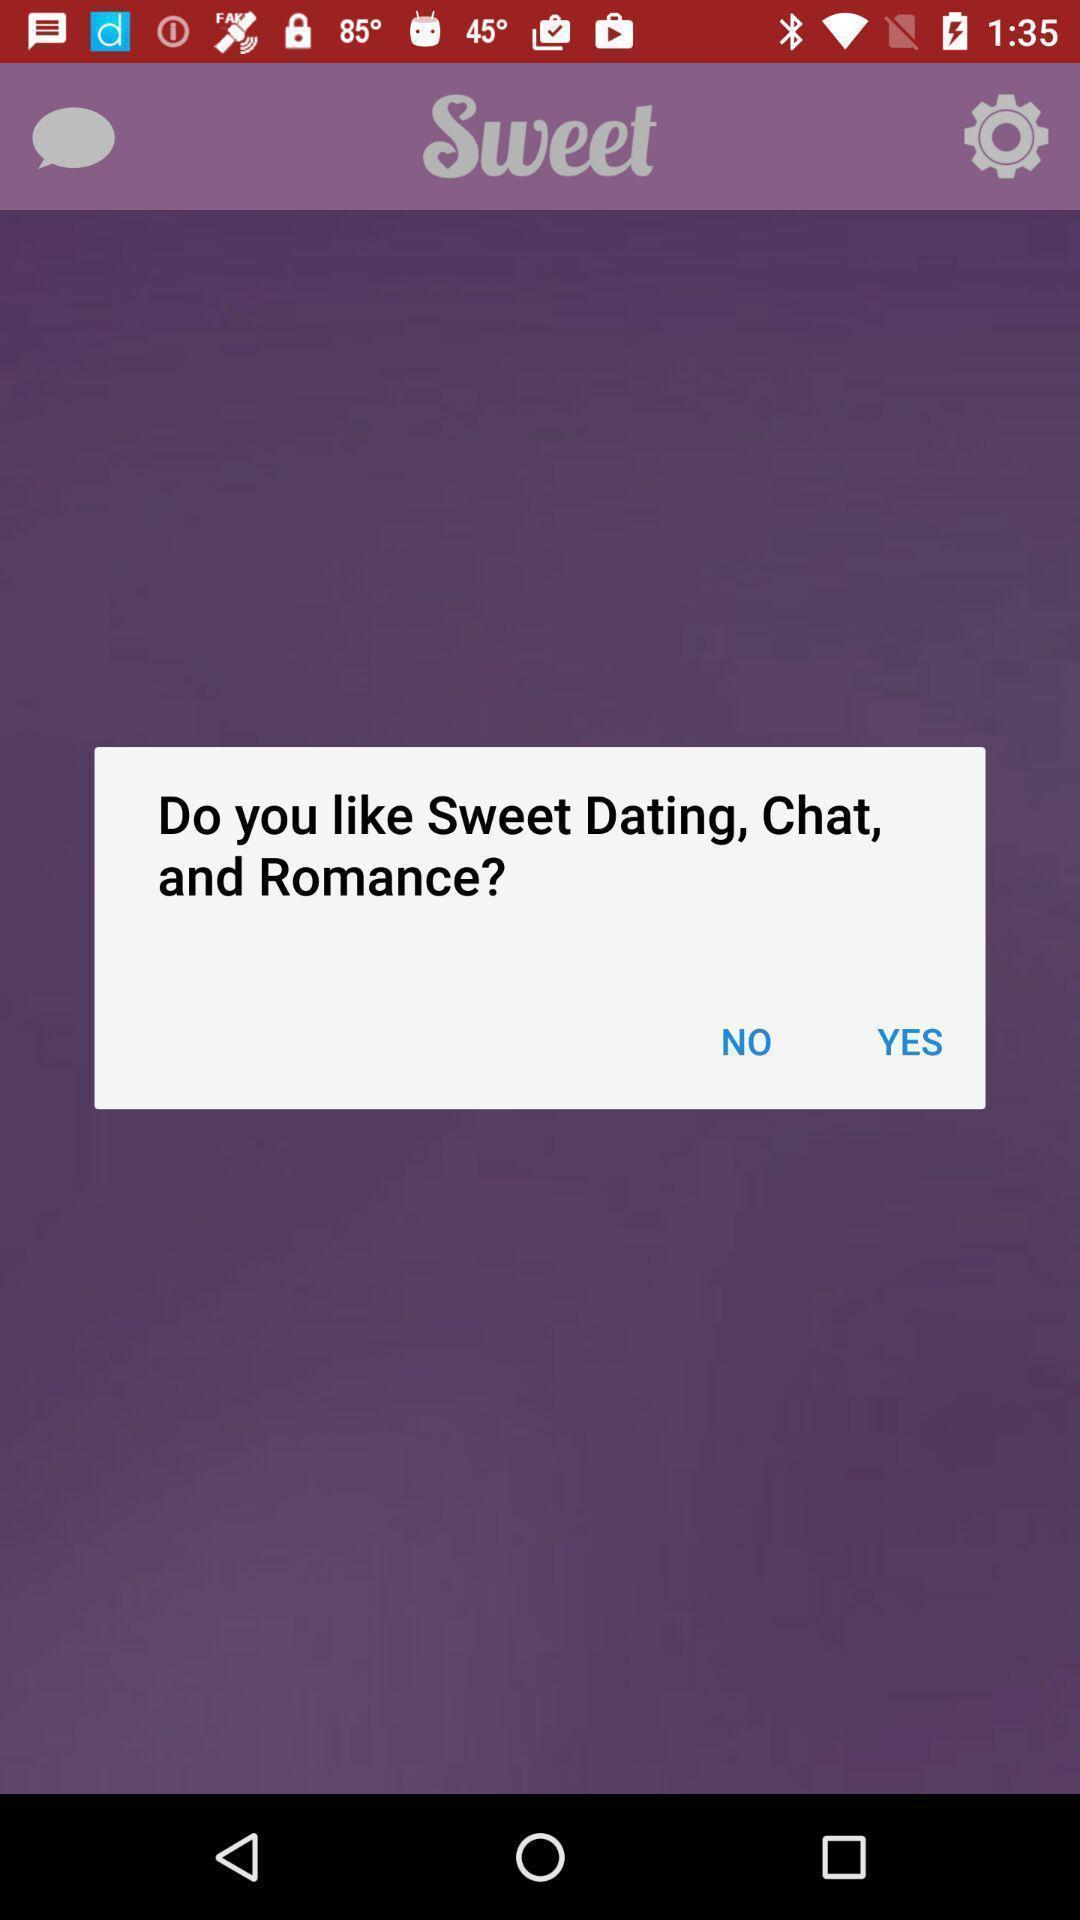Tell me about the visual elements in this screen capture. Pop-up shows an option. 